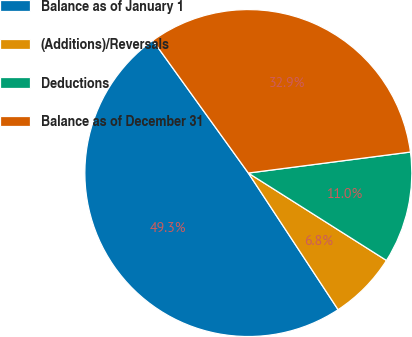<chart> <loc_0><loc_0><loc_500><loc_500><pie_chart><fcel>Balance as of January 1<fcel>(Additions)/Reversals<fcel>Deductions<fcel>Balance as of December 31<nl><fcel>49.32%<fcel>6.77%<fcel>11.03%<fcel>32.88%<nl></chart> 